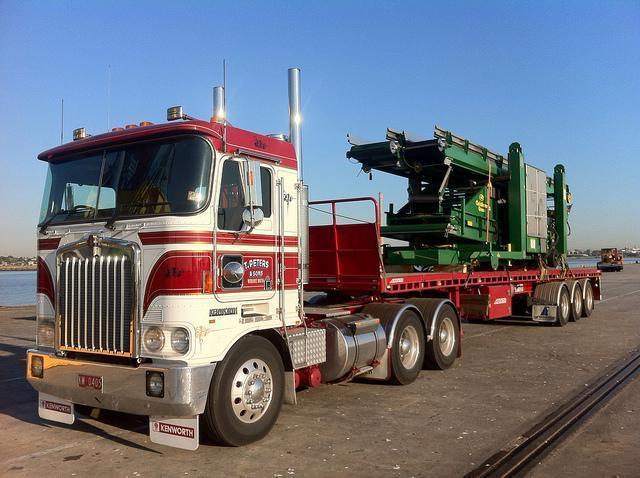How many small cars are in the image?
Give a very brief answer. 0. 